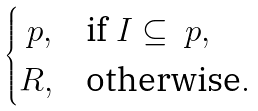Convert formula to latex. <formula><loc_0><loc_0><loc_500><loc_500>\begin{cases} \ p , & \text {if } I \subseteq \ p , \\ R , & \text {otherwise} . \end{cases}</formula> 